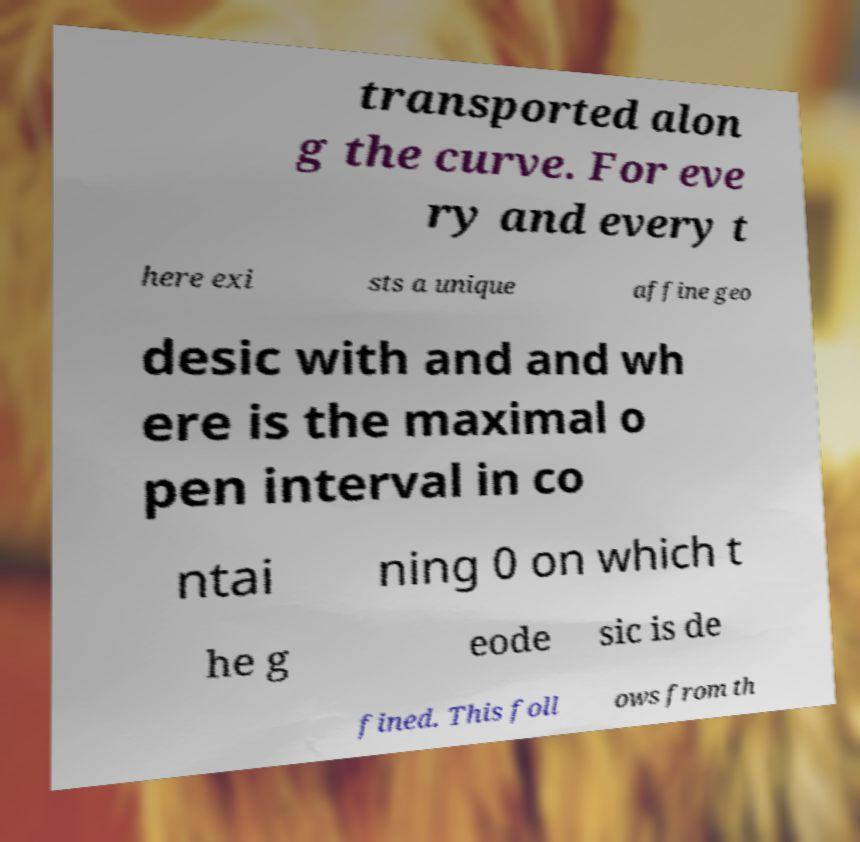For documentation purposes, I need the text within this image transcribed. Could you provide that? transported alon g the curve. For eve ry and every t here exi sts a unique affine geo desic with and and wh ere is the maximal o pen interval in co ntai ning 0 on which t he g eode sic is de fined. This foll ows from th 